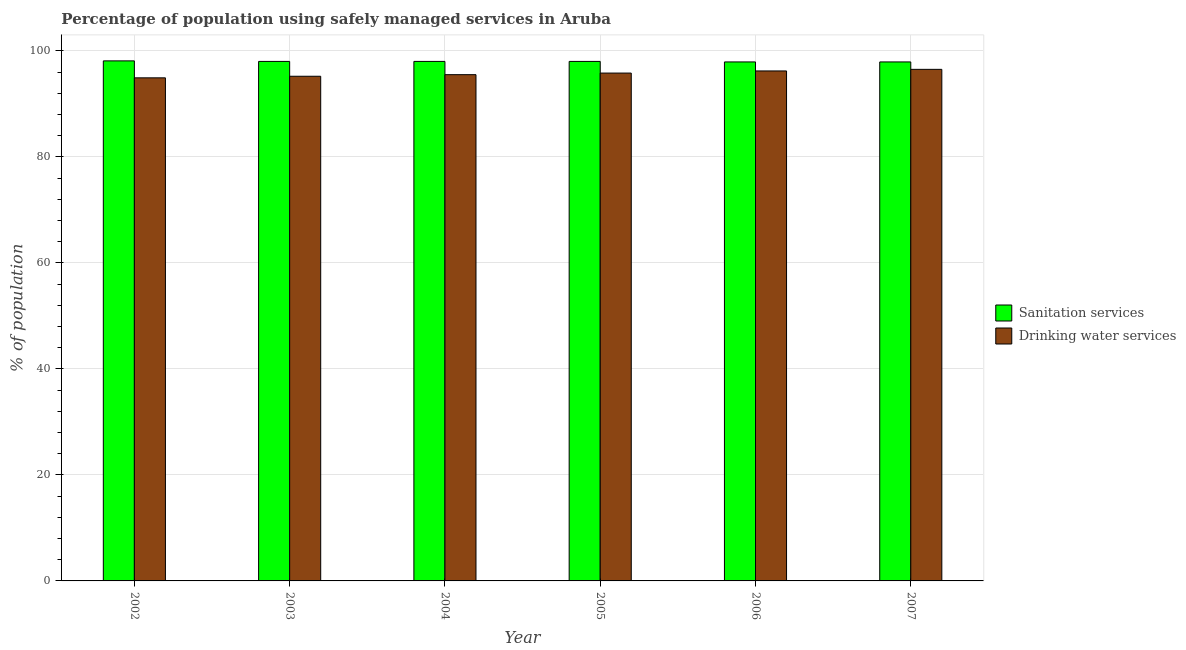How many different coloured bars are there?
Provide a short and direct response. 2. How many groups of bars are there?
Offer a very short reply. 6. Are the number of bars per tick equal to the number of legend labels?
Keep it short and to the point. Yes. How many bars are there on the 6th tick from the left?
Make the answer very short. 2. What is the label of the 3rd group of bars from the left?
Provide a succinct answer. 2004. What is the percentage of population who used drinking water services in 2007?
Your response must be concise. 96.5. Across all years, what is the maximum percentage of population who used drinking water services?
Offer a very short reply. 96.5. Across all years, what is the minimum percentage of population who used drinking water services?
Ensure brevity in your answer.  94.9. In which year was the percentage of population who used sanitation services maximum?
Your answer should be very brief. 2002. What is the total percentage of population who used drinking water services in the graph?
Your answer should be very brief. 574.1. What is the difference between the percentage of population who used sanitation services in 2005 and that in 2007?
Give a very brief answer. 0.1. What is the difference between the percentage of population who used drinking water services in 2005 and the percentage of population who used sanitation services in 2006?
Give a very brief answer. -0.4. What is the average percentage of population who used sanitation services per year?
Make the answer very short. 97.98. In the year 2007, what is the difference between the percentage of population who used drinking water services and percentage of population who used sanitation services?
Offer a very short reply. 0. What is the ratio of the percentage of population who used sanitation services in 2004 to that in 2007?
Give a very brief answer. 1. Is the difference between the percentage of population who used drinking water services in 2002 and 2003 greater than the difference between the percentage of population who used sanitation services in 2002 and 2003?
Offer a very short reply. No. What is the difference between the highest and the second highest percentage of population who used sanitation services?
Your response must be concise. 0.1. What is the difference between the highest and the lowest percentage of population who used drinking water services?
Your answer should be compact. 1.6. In how many years, is the percentage of population who used sanitation services greater than the average percentage of population who used sanitation services taken over all years?
Provide a short and direct response. 4. What does the 1st bar from the left in 2007 represents?
Your answer should be compact. Sanitation services. What does the 2nd bar from the right in 2002 represents?
Give a very brief answer. Sanitation services. Are all the bars in the graph horizontal?
Your answer should be very brief. No. Are the values on the major ticks of Y-axis written in scientific E-notation?
Provide a succinct answer. No. Where does the legend appear in the graph?
Make the answer very short. Center right. How are the legend labels stacked?
Offer a terse response. Vertical. What is the title of the graph?
Give a very brief answer. Percentage of population using safely managed services in Aruba. Does "Public credit registry" appear as one of the legend labels in the graph?
Your response must be concise. No. What is the label or title of the Y-axis?
Keep it short and to the point. % of population. What is the % of population in Sanitation services in 2002?
Keep it short and to the point. 98.1. What is the % of population of Drinking water services in 2002?
Give a very brief answer. 94.9. What is the % of population of Sanitation services in 2003?
Give a very brief answer. 98. What is the % of population of Drinking water services in 2003?
Your response must be concise. 95.2. What is the % of population in Drinking water services in 2004?
Provide a short and direct response. 95.5. What is the % of population of Sanitation services in 2005?
Offer a very short reply. 98. What is the % of population of Drinking water services in 2005?
Keep it short and to the point. 95.8. What is the % of population of Sanitation services in 2006?
Offer a terse response. 97.9. What is the % of population in Drinking water services in 2006?
Offer a terse response. 96.2. What is the % of population of Sanitation services in 2007?
Your answer should be very brief. 97.9. What is the % of population in Drinking water services in 2007?
Ensure brevity in your answer.  96.5. Across all years, what is the maximum % of population in Sanitation services?
Make the answer very short. 98.1. Across all years, what is the maximum % of population of Drinking water services?
Make the answer very short. 96.5. Across all years, what is the minimum % of population in Sanitation services?
Ensure brevity in your answer.  97.9. Across all years, what is the minimum % of population of Drinking water services?
Your answer should be very brief. 94.9. What is the total % of population in Sanitation services in the graph?
Provide a succinct answer. 587.9. What is the total % of population in Drinking water services in the graph?
Keep it short and to the point. 574.1. What is the difference between the % of population in Drinking water services in 2002 and that in 2005?
Make the answer very short. -0.9. What is the difference between the % of population in Drinking water services in 2002 and that in 2006?
Keep it short and to the point. -1.3. What is the difference between the % of population in Drinking water services in 2003 and that in 2004?
Provide a short and direct response. -0.3. What is the difference between the % of population of Sanitation services in 2003 and that in 2006?
Give a very brief answer. 0.1. What is the difference between the % of population in Sanitation services in 2003 and that in 2007?
Provide a succinct answer. 0.1. What is the difference between the % of population of Drinking water services in 2003 and that in 2007?
Provide a succinct answer. -1.3. What is the difference between the % of population in Drinking water services in 2004 and that in 2005?
Ensure brevity in your answer.  -0.3. What is the difference between the % of population in Sanitation services in 2004 and that in 2007?
Offer a very short reply. 0.1. What is the difference between the % of population of Drinking water services in 2005 and that in 2006?
Your answer should be very brief. -0.4. What is the difference between the % of population in Sanitation services in 2005 and that in 2007?
Provide a short and direct response. 0.1. What is the difference between the % of population of Sanitation services in 2002 and the % of population of Drinking water services in 2005?
Your answer should be very brief. 2.3. What is the difference between the % of population in Sanitation services in 2002 and the % of population in Drinking water services in 2006?
Give a very brief answer. 1.9. What is the difference between the % of population in Sanitation services in 2003 and the % of population in Drinking water services in 2004?
Your response must be concise. 2.5. What is the difference between the % of population of Sanitation services in 2003 and the % of population of Drinking water services in 2005?
Provide a short and direct response. 2.2. What is the difference between the % of population in Sanitation services in 2003 and the % of population in Drinking water services in 2007?
Ensure brevity in your answer.  1.5. What is the difference between the % of population in Sanitation services in 2004 and the % of population in Drinking water services in 2005?
Keep it short and to the point. 2.2. What is the difference between the % of population in Sanitation services in 2004 and the % of population in Drinking water services in 2007?
Ensure brevity in your answer.  1.5. What is the difference between the % of population of Sanitation services in 2006 and the % of population of Drinking water services in 2007?
Ensure brevity in your answer.  1.4. What is the average % of population of Sanitation services per year?
Make the answer very short. 97.98. What is the average % of population of Drinking water services per year?
Provide a succinct answer. 95.68. In the year 2002, what is the difference between the % of population of Sanitation services and % of population of Drinking water services?
Make the answer very short. 3.2. In the year 2004, what is the difference between the % of population in Sanitation services and % of population in Drinking water services?
Provide a short and direct response. 2.5. In the year 2005, what is the difference between the % of population of Sanitation services and % of population of Drinking water services?
Provide a succinct answer. 2.2. In the year 2006, what is the difference between the % of population of Sanitation services and % of population of Drinking water services?
Keep it short and to the point. 1.7. In the year 2007, what is the difference between the % of population of Sanitation services and % of population of Drinking water services?
Your answer should be very brief. 1.4. What is the ratio of the % of population of Drinking water services in 2002 to that in 2005?
Keep it short and to the point. 0.99. What is the ratio of the % of population in Sanitation services in 2002 to that in 2006?
Offer a terse response. 1. What is the ratio of the % of population of Drinking water services in 2002 to that in 2006?
Provide a short and direct response. 0.99. What is the ratio of the % of population in Sanitation services in 2002 to that in 2007?
Your answer should be compact. 1. What is the ratio of the % of population in Drinking water services in 2002 to that in 2007?
Offer a very short reply. 0.98. What is the ratio of the % of population in Sanitation services in 2003 to that in 2004?
Offer a terse response. 1. What is the ratio of the % of population of Drinking water services in 2003 to that in 2005?
Offer a very short reply. 0.99. What is the ratio of the % of population of Drinking water services in 2003 to that in 2006?
Ensure brevity in your answer.  0.99. What is the ratio of the % of population of Sanitation services in 2003 to that in 2007?
Offer a terse response. 1. What is the ratio of the % of population of Drinking water services in 2003 to that in 2007?
Ensure brevity in your answer.  0.99. What is the ratio of the % of population of Sanitation services in 2004 to that in 2005?
Offer a very short reply. 1. What is the ratio of the % of population in Drinking water services in 2004 to that in 2007?
Offer a terse response. 0.99. What is the ratio of the % of population in Sanitation services in 2005 to that in 2007?
Your answer should be very brief. 1. What is the ratio of the % of population in Drinking water services in 2005 to that in 2007?
Ensure brevity in your answer.  0.99. What is the difference between the highest and the second highest % of population of Sanitation services?
Offer a very short reply. 0.1. What is the difference between the highest and the lowest % of population in Sanitation services?
Keep it short and to the point. 0.2. 